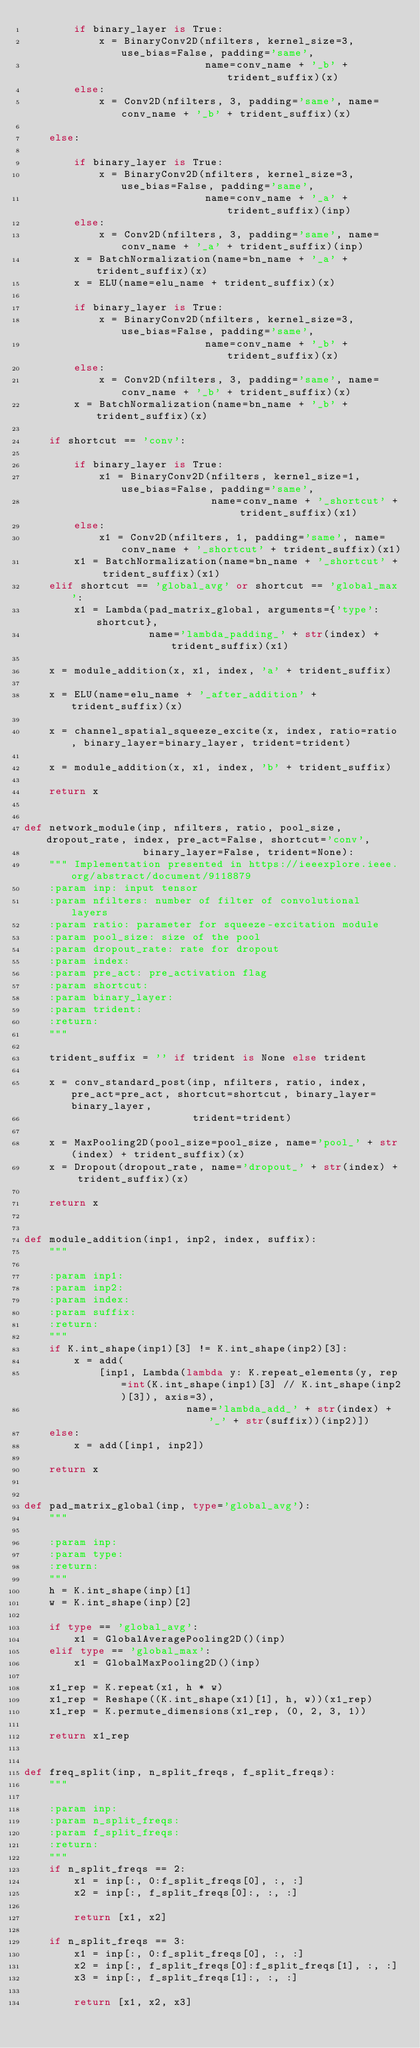<code> <loc_0><loc_0><loc_500><loc_500><_Python_>        if binary_layer is True:
            x = BinaryConv2D(nfilters, kernel_size=3, use_bias=False, padding='same',
                             name=conv_name + '_b' + trident_suffix)(x)
        else:
            x = Conv2D(nfilters, 3, padding='same', name=conv_name + '_b' + trident_suffix)(x)

    else:

        if binary_layer is True:
            x = BinaryConv2D(nfilters, kernel_size=3, use_bias=False, padding='same',
                             name=conv_name + '_a' + trident_suffix)(inp)
        else:
            x = Conv2D(nfilters, 3, padding='same', name=conv_name + '_a' + trident_suffix)(inp)
        x = BatchNormalization(name=bn_name + '_a' + trident_suffix)(x)
        x = ELU(name=elu_name + trident_suffix)(x)

        if binary_layer is True:
            x = BinaryConv2D(nfilters, kernel_size=3, use_bias=False, padding='same',
                             name=conv_name + '_b' + trident_suffix)(x)
        else:
            x = Conv2D(nfilters, 3, padding='same', name=conv_name + '_b' + trident_suffix)(x)
        x = BatchNormalization(name=bn_name + '_b' + trident_suffix)(x)

    if shortcut == 'conv':

        if binary_layer is True:
            x1 = BinaryConv2D(nfilters, kernel_size=1, use_bias=False, padding='same',
                              name=conv_name + '_shortcut' + trident_suffix)(x1)
        else:
            x1 = Conv2D(nfilters, 1, padding='same', name=conv_name + '_shortcut' + trident_suffix)(x1)
        x1 = BatchNormalization(name=bn_name + '_shortcut' + trident_suffix)(x1)
    elif shortcut == 'global_avg' or shortcut == 'global_max':
        x1 = Lambda(pad_matrix_global, arguments={'type': shortcut},
                    name='lambda_padding_' + str(index) + trident_suffix)(x1)

    x = module_addition(x, x1, index, 'a' + trident_suffix)

    x = ELU(name=elu_name + '_after_addition' + trident_suffix)(x)

    x = channel_spatial_squeeze_excite(x, index, ratio=ratio, binary_layer=binary_layer, trident=trident)

    x = module_addition(x, x1, index, 'b' + trident_suffix)

    return x


def network_module(inp, nfilters, ratio, pool_size, dropout_rate, index, pre_act=False, shortcut='conv',
                   binary_layer=False, trident=None):
    """ Implementation presented in https://ieeexplore.ieee.org/abstract/document/9118879
    :param inp: input tensor
    :param nfilters: number of filter of convolutional layers
    :param ratio: parameter for squeeze-excitation module
    :param pool_size: size of the pool
    :param dropout_rate: rate for dropout
    :param index:
    :param pre_act: pre_activation flag
    :param shortcut:
    :param binary_layer:
    :param trident:
    :return:
    """

    trident_suffix = '' if trident is None else trident

    x = conv_standard_post(inp, nfilters, ratio, index, pre_act=pre_act, shortcut=shortcut, binary_layer=binary_layer,
                           trident=trident)

    x = MaxPooling2D(pool_size=pool_size, name='pool_' + str(index) + trident_suffix)(x)
    x = Dropout(dropout_rate, name='dropout_' + str(index) + trident_suffix)(x)

    return x


def module_addition(inp1, inp2, index, suffix):
    """

    :param inp1:
    :param inp2:
    :param index:
    :param suffix:
    :return:
    """
    if K.int_shape(inp1)[3] != K.int_shape(inp2)[3]:
        x = add(
            [inp1, Lambda(lambda y: K.repeat_elements(y, rep=int(K.int_shape(inp1)[3] // K.int_shape(inp2)[3]), axis=3),
                          name='lambda_add_' + str(index) + '_' + str(suffix))(inp2)])
    else:
        x = add([inp1, inp2])

    return x


def pad_matrix_global(inp, type='global_avg'):
    """

    :param inp:
    :param type:
    :return:
    """
    h = K.int_shape(inp)[1]
    w = K.int_shape(inp)[2]

    if type == 'global_avg':
        x1 = GlobalAveragePooling2D()(inp)
    elif type == 'global_max':
        x1 = GlobalMaxPooling2D()(inp)

    x1_rep = K.repeat(x1, h * w)
    x1_rep = Reshape((K.int_shape(x1)[1], h, w))(x1_rep)
    x1_rep = K.permute_dimensions(x1_rep, (0, 2, 3, 1))

    return x1_rep


def freq_split(inp, n_split_freqs, f_split_freqs):
    """

    :param inp:
    :param n_split_freqs:
    :param f_split_freqs:
    :return:
    """
    if n_split_freqs == 2:
        x1 = inp[:, 0:f_split_freqs[0], :, :]
        x2 = inp[:, f_split_freqs[0]:, :, :]

        return [x1, x2]

    if n_split_freqs == 3:
        x1 = inp[:, 0:f_split_freqs[0], :, :]
        x2 = inp[:, f_split_freqs[0]:f_split_freqs[1], :, :]
        x3 = inp[:, f_split_freqs[1]:, :, :]

        return [x1, x2, x3]
</code> 